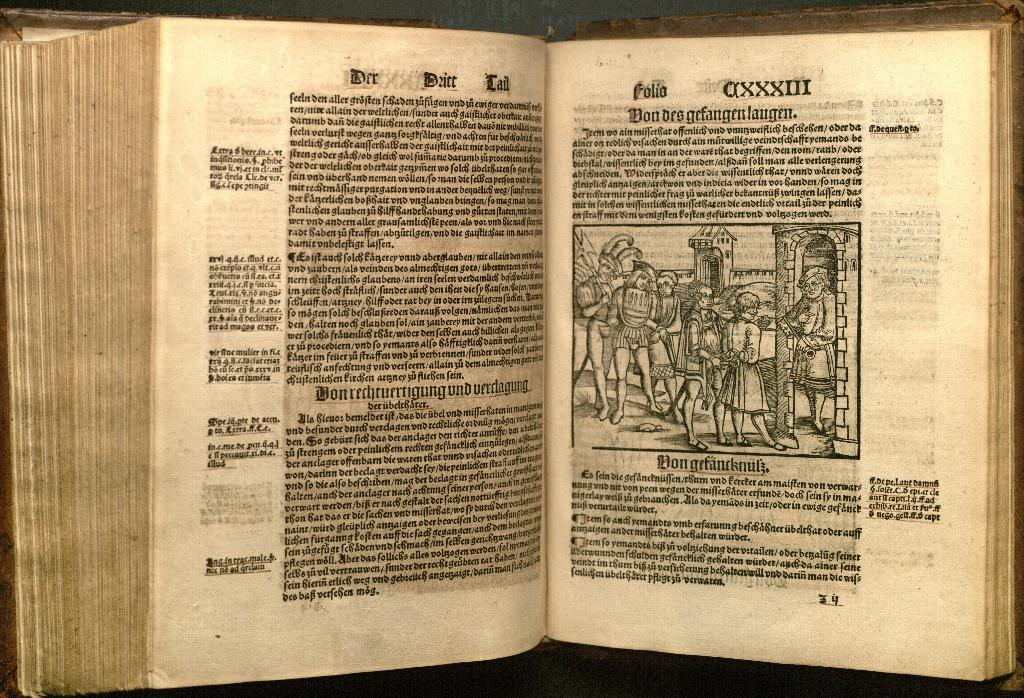<image>
Share a concise interpretation of the image provided. A book with aged pages is open to page 34. 